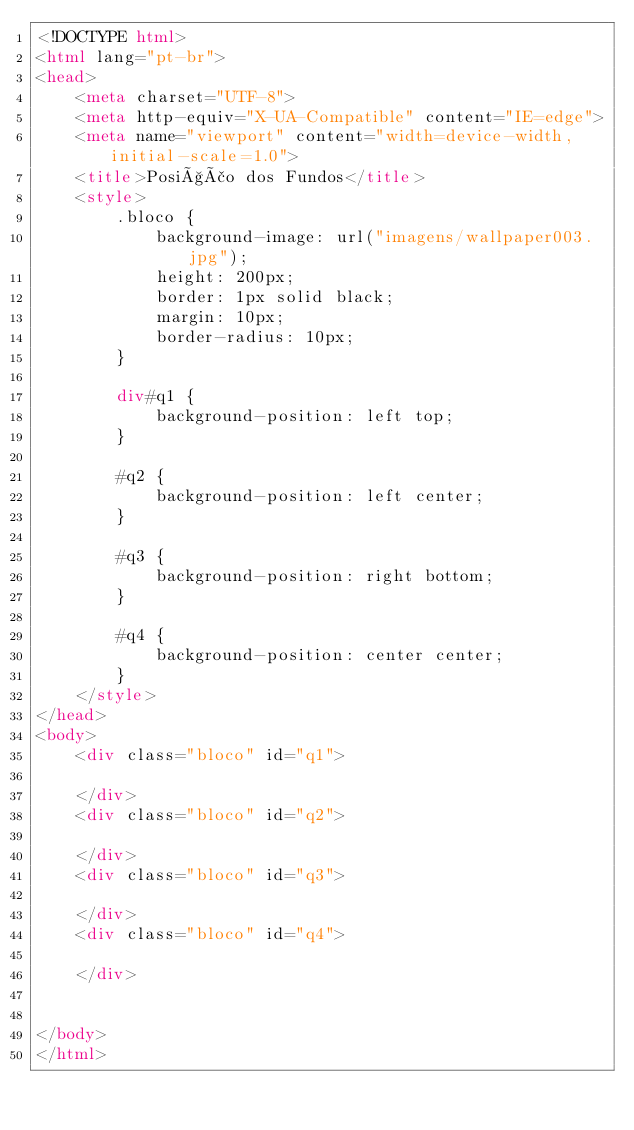Convert code to text. <code><loc_0><loc_0><loc_500><loc_500><_HTML_><!DOCTYPE html>
<html lang="pt-br">
<head>
    <meta charset="UTF-8">
    <meta http-equiv="X-UA-Compatible" content="IE=edge">
    <meta name="viewport" content="width=device-width, initial-scale=1.0">
    <title>Posição dos Fundos</title>
    <style>
        .bloco {
            background-image: url("imagens/wallpaper003.jpg");
            height: 200px;
            border: 1px solid black;
            margin: 10px;
            border-radius: 10px;
        }

        div#q1 {
            background-position: left top;
        }

        #q2 {
            background-position: left center;
        }

        #q3 {
            background-position: right bottom;
        }

        #q4 {
            background-position: center center;
        }
    </style>
</head>
<body>
    <div class="bloco" id="q1">

    </div>
    <div class="bloco" id="q2">

    </div>
    <div class="bloco" id="q3">

    </div>
    <div class="bloco" id="q4">

    </div>
 

</body>
</html></code> 